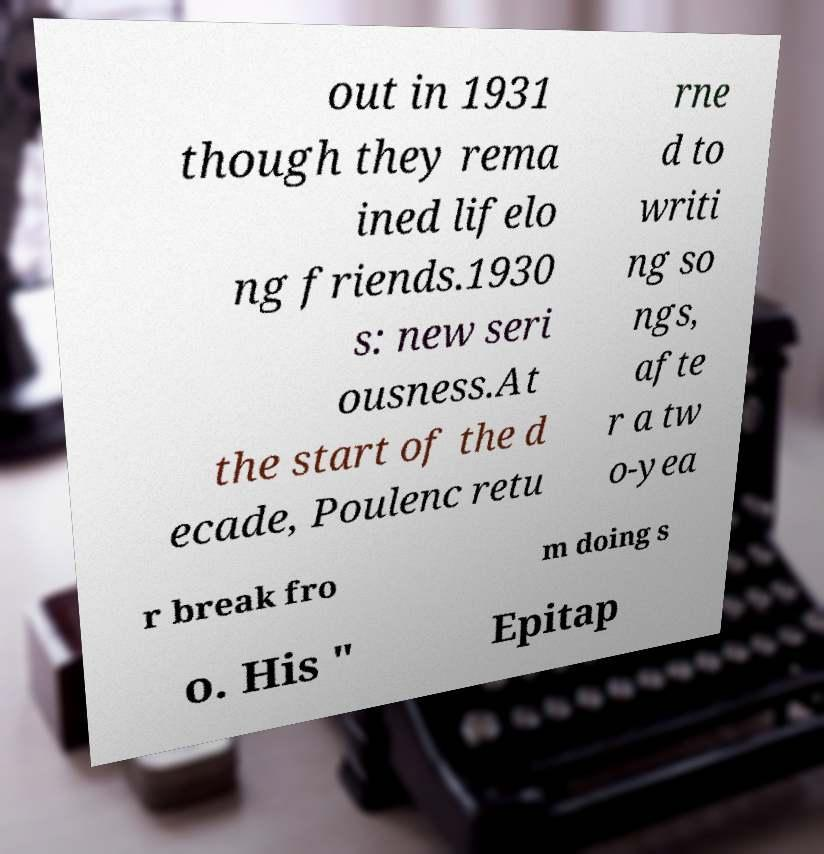Please read and relay the text visible in this image. What does it say? out in 1931 though they rema ined lifelo ng friends.1930 s: new seri ousness.At the start of the d ecade, Poulenc retu rne d to writi ng so ngs, afte r a tw o-yea r break fro m doing s o. His " Epitap 